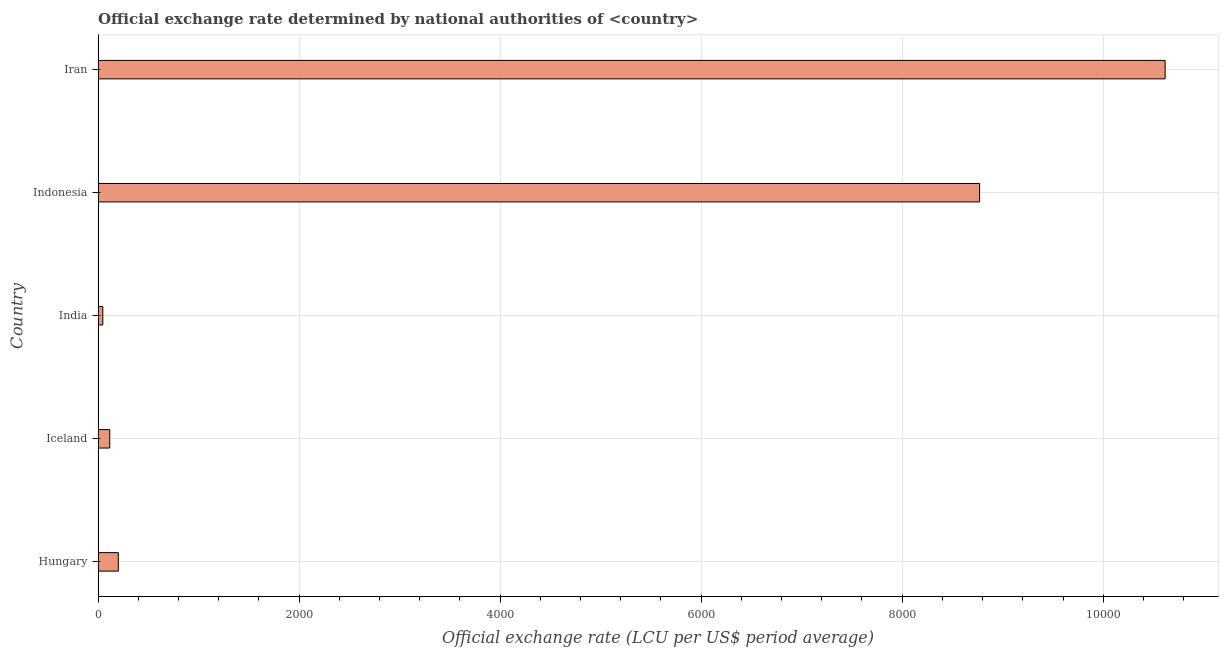Does the graph contain grids?
Ensure brevity in your answer.  Yes. What is the title of the graph?
Your answer should be compact. Official exchange rate determined by national authorities of <country>. What is the label or title of the X-axis?
Your answer should be very brief. Official exchange rate (LCU per US$ period average). What is the official exchange rate in Hungary?
Provide a succinct answer. 201.06. Across all countries, what is the maximum official exchange rate?
Your response must be concise. 1.06e+04. Across all countries, what is the minimum official exchange rate?
Provide a succinct answer. 46.67. In which country was the official exchange rate maximum?
Your answer should be very brief. Iran. In which country was the official exchange rate minimum?
Keep it short and to the point. India. What is the sum of the official exchange rate?
Ensure brevity in your answer.  1.98e+04. What is the difference between the official exchange rate in India and Indonesia?
Offer a terse response. -8723.76. What is the average official exchange rate per country?
Your response must be concise. 3950.08. What is the median official exchange rate?
Give a very brief answer. 201.06. What is the ratio of the official exchange rate in Hungary to that in Iceland?
Provide a short and direct response. 1.73. Is the official exchange rate in India less than that in Iran?
Your answer should be compact. Yes. Is the difference between the official exchange rate in Indonesia and Iran greater than the difference between any two countries?
Your answer should be compact. No. What is the difference between the highest and the second highest official exchange rate?
Make the answer very short. 1845.87. Is the sum of the official exchange rate in Iceland and Indonesia greater than the maximum official exchange rate across all countries?
Keep it short and to the point. No. What is the difference between the highest and the lowest official exchange rate?
Ensure brevity in your answer.  1.06e+04. In how many countries, is the official exchange rate greater than the average official exchange rate taken over all countries?
Offer a very short reply. 2. How many bars are there?
Your answer should be very brief. 5. What is the difference between two consecutive major ticks on the X-axis?
Your answer should be compact. 2000. Are the values on the major ticks of X-axis written in scientific E-notation?
Make the answer very short. No. What is the Official exchange rate (LCU per US$ period average) of Hungary?
Keep it short and to the point. 201.06. What is the Official exchange rate (LCU per US$ period average) in Iceland?
Provide a short and direct response. 115.95. What is the Official exchange rate (LCU per US$ period average) in India?
Offer a very short reply. 46.67. What is the Official exchange rate (LCU per US$ period average) in Indonesia?
Your response must be concise. 8770.43. What is the Official exchange rate (LCU per US$ period average) in Iran?
Give a very brief answer. 1.06e+04. What is the difference between the Official exchange rate (LCU per US$ period average) in Hungary and Iceland?
Give a very brief answer. 85.1. What is the difference between the Official exchange rate (LCU per US$ period average) in Hungary and India?
Ensure brevity in your answer.  154.38. What is the difference between the Official exchange rate (LCU per US$ period average) in Hungary and Indonesia?
Your answer should be very brief. -8569.38. What is the difference between the Official exchange rate (LCU per US$ period average) in Hungary and Iran?
Give a very brief answer. -1.04e+04. What is the difference between the Official exchange rate (LCU per US$ period average) in Iceland and India?
Provide a succinct answer. 69.28. What is the difference between the Official exchange rate (LCU per US$ period average) in Iceland and Indonesia?
Offer a terse response. -8654.48. What is the difference between the Official exchange rate (LCU per US$ period average) in Iceland and Iran?
Give a very brief answer. -1.05e+04. What is the difference between the Official exchange rate (LCU per US$ period average) in India and Indonesia?
Your answer should be compact. -8723.76. What is the difference between the Official exchange rate (LCU per US$ period average) in India and Iran?
Your response must be concise. -1.06e+04. What is the difference between the Official exchange rate (LCU per US$ period average) in Indonesia and Iran?
Ensure brevity in your answer.  -1845.87. What is the ratio of the Official exchange rate (LCU per US$ period average) in Hungary to that in Iceland?
Your response must be concise. 1.73. What is the ratio of the Official exchange rate (LCU per US$ period average) in Hungary to that in India?
Ensure brevity in your answer.  4.31. What is the ratio of the Official exchange rate (LCU per US$ period average) in Hungary to that in Indonesia?
Your answer should be very brief. 0.02. What is the ratio of the Official exchange rate (LCU per US$ period average) in Hungary to that in Iran?
Make the answer very short. 0.02. What is the ratio of the Official exchange rate (LCU per US$ period average) in Iceland to that in India?
Make the answer very short. 2.48. What is the ratio of the Official exchange rate (LCU per US$ period average) in Iceland to that in Indonesia?
Make the answer very short. 0.01. What is the ratio of the Official exchange rate (LCU per US$ period average) in Iceland to that in Iran?
Keep it short and to the point. 0.01. What is the ratio of the Official exchange rate (LCU per US$ period average) in India to that in Indonesia?
Your answer should be very brief. 0.01. What is the ratio of the Official exchange rate (LCU per US$ period average) in India to that in Iran?
Give a very brief answer. 0. What is the ratio of the Official exchange rate (LCU per US$ period average) in Indonesia to that in Iran?
Ensure brevity in your answer.  0.83. 